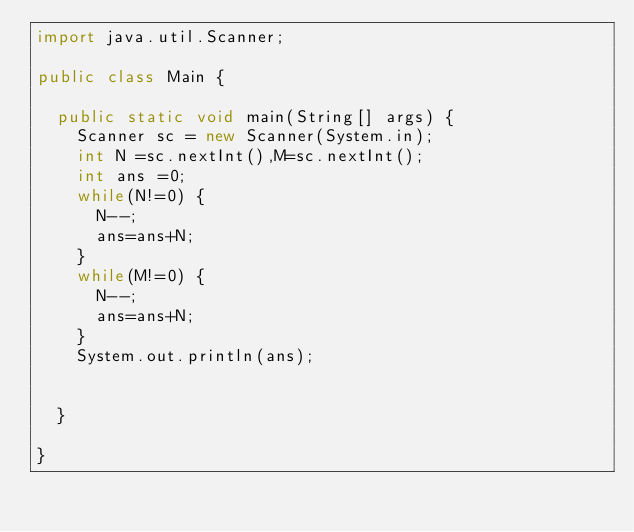<code> <loc_0><loc_0><loc_500><loc_500><_Java_>import java.util.Scanner;

public class Main {

	public static void main(String[] args) {
		Scanner sc = new Scanner(System.in);
		int N =sc.nextInt(),M=sc.nextInt();
		int ans =0;
		while(N!=0) {
			N--;
			ans=ans+N;
		}
		while(M!=0) {
			N--;
			ans=ans+N;
		}
		System.out.println(ans);
		

	}

}
</code> 